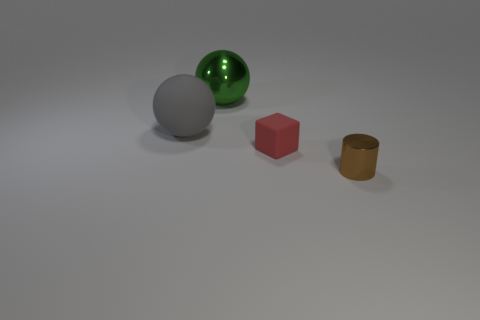There is a green sphere; is it the same size as the metallic thing that is in front of the green metallic ball?
Make the answer very short. No. Are there any metallic things that have the same size as the shiny sphere?
Provide a short and direct response. No. What number of other objects are the same material as the tiny block?
Offer a terse response. 1. There is a thing that is behind the cylinder and in front of the gray sphere; what is its color?
Your answer should be very brief. Red. Are the thing that is left of the shiny sphere and the small thing that is behind the shiny cylinder made of the same material?
Ensure brevity in your answer.  Yes. There is a metal object in front of the red rubber block; is it the same size as the tiny block?
Give a very brief answer. Yes. There is a rubber sphere; is its color the same as the large ball to the right of the big gray object?
Offer a very short reply. No. There is a large gray matte object; what shape is it?
Offer a terse response. Sphere. Do the tiny shiny thing and the rubber ball have the same color?
Make the answer very short. No. How many things are either large balls in front of the big green shiny ball or brown cylinders?
Your answer should be compact. 2. 